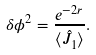Convert formula to latex. <formula><loc_0><loc_0><loc_500><loc_500>\delta \phi ^ { 2 } = \frac { e ^ { - 2 r } } { \langle \hat { J } _ { 1 } \rangle } .</formula> 